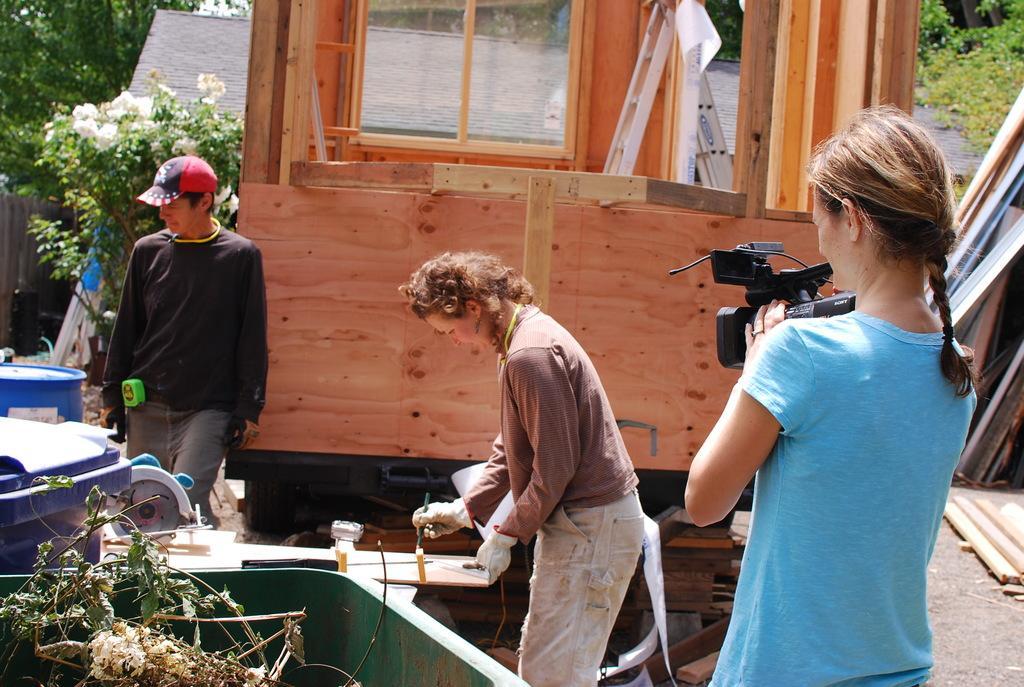Please provide a concise description of this image. In this image in the foreground there is one woman who is standing and she is holding a camera, and in the center there is one women who is standing and she is painting. On the left side there is one man who is standing, and in the background there is a wooden house and some trees, plants, flowers and some sticks. At the bottom there are some wooden boxes and some containers and some grass, in the background there is a beach. 